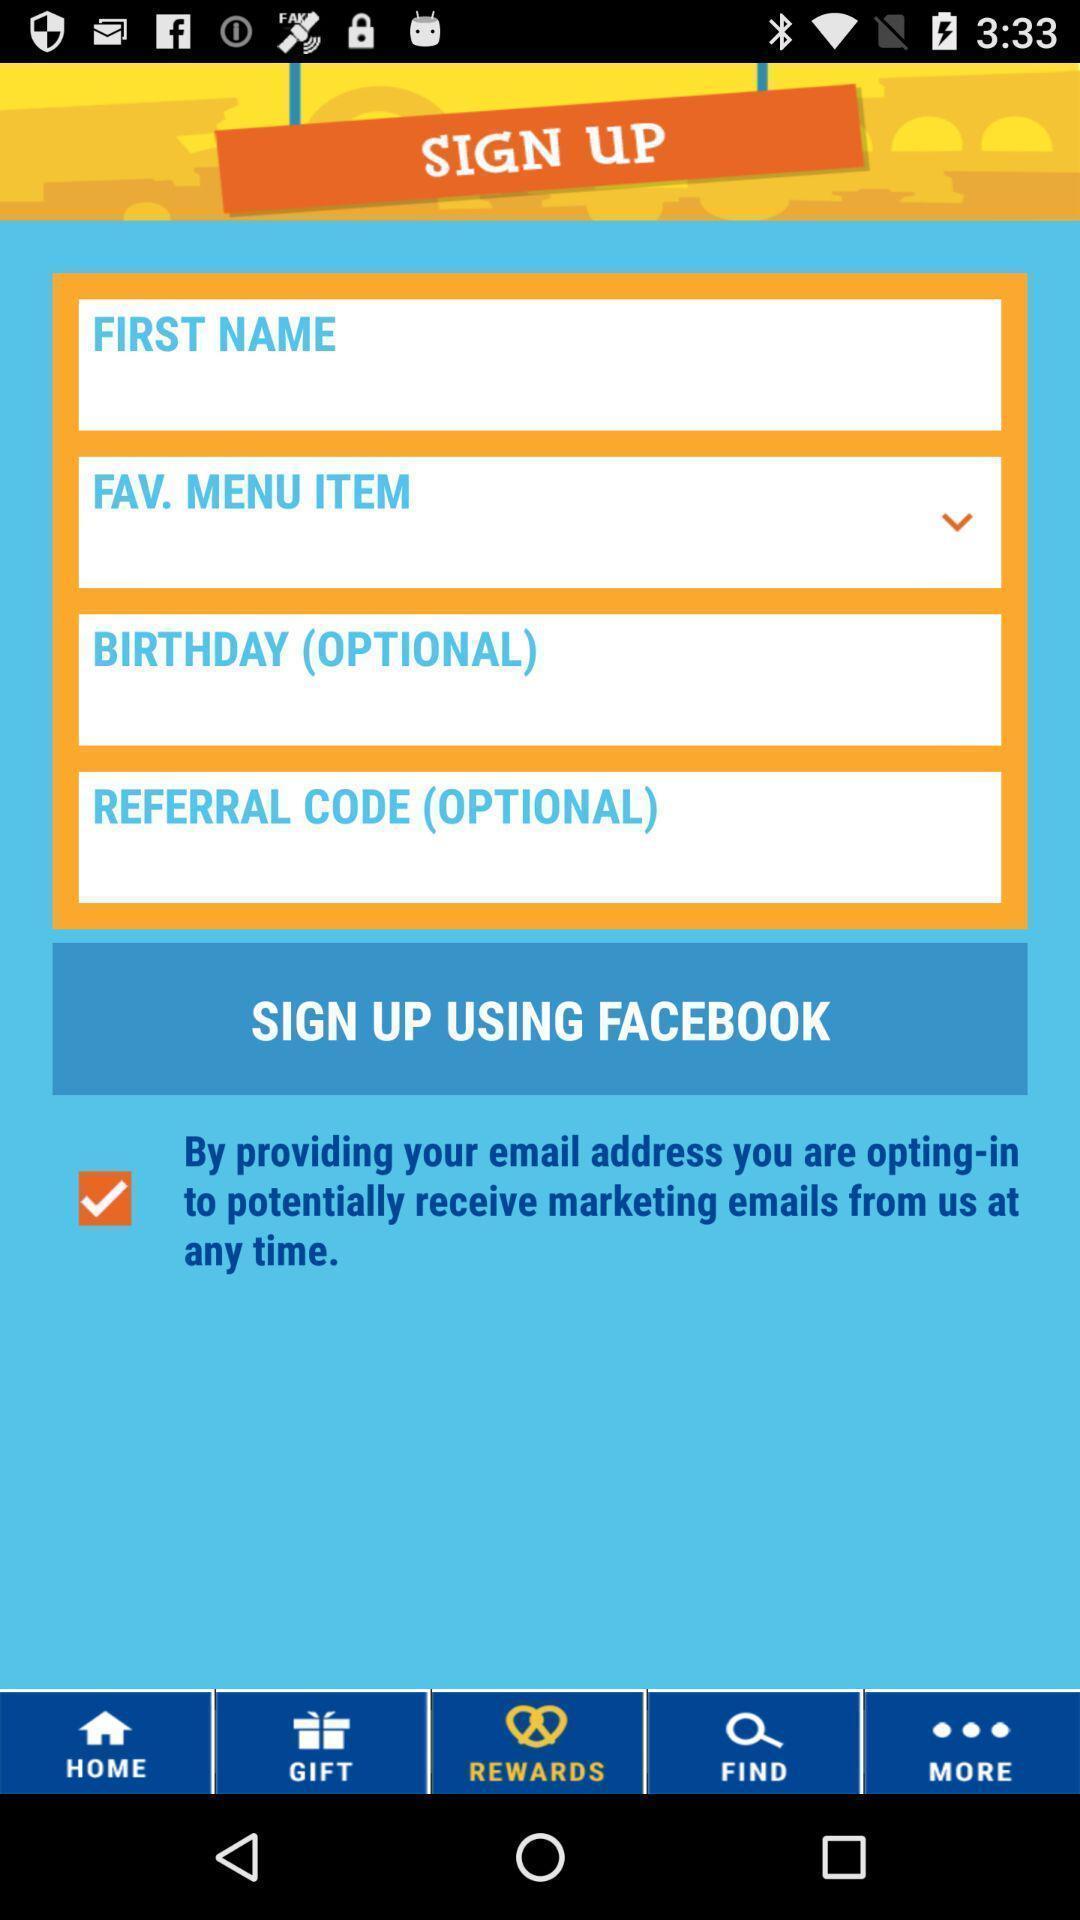Tell me about the visual elements in this screen capture. Sign up page. 